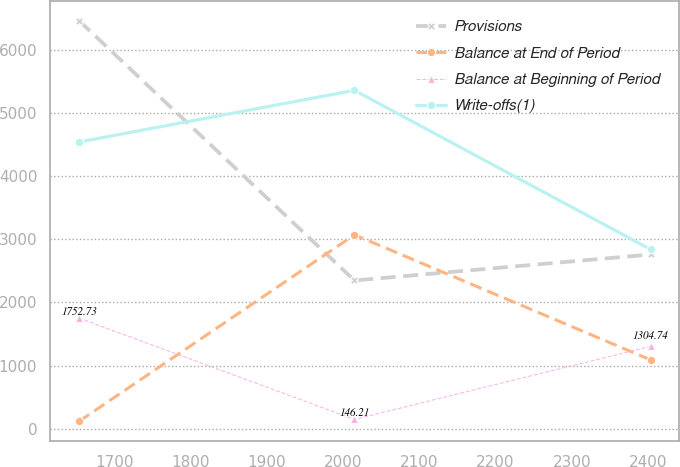Convert chart to OTSL. <chart><loc_0><loc_0><loc_500><loc_500><line_chart><ecel><fcel>Provisions<fcel>Balance at End of Period<fcel>Balance at Beginning of Period<fcel>Write-offs(1)<nl><fcel>1653.57<fcel>6466.53<fcel>115.51<fcel>1752.73<fcel>4543.2<nl><fcel>2014.88<fcel>2348.59<fcel>3072.34<fcel>146.21<fcel>5361.64<nl><fcel>2403.37<fcel>2760.38<fcel>1090.09<fcel>1304.74<fcel>2840.08<nl></chart> 